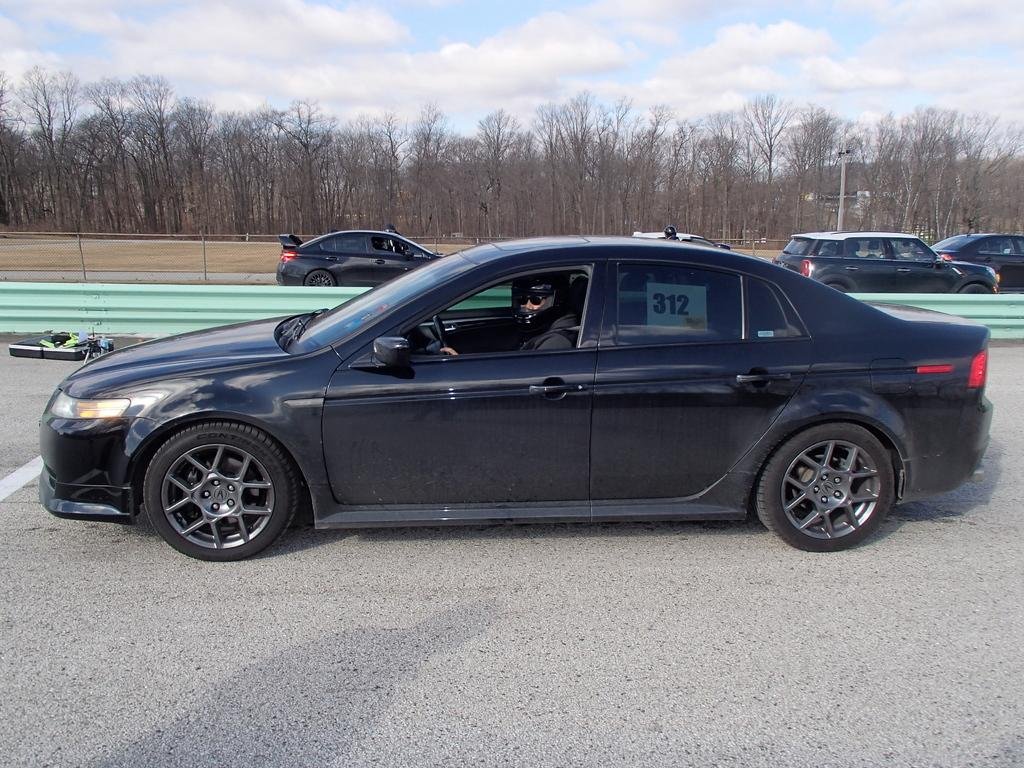What is the person in the image doing? The person is sitting inside a car. What protective gear is the person wearing? The person is wearing a helmet. What can be seen on the road in the image? There are cars on the road. What type of barrier is present in the image? There is a fence in the image. What is visible in the background of the image? There is a pole, trees, and the sky with clouds visible in the background. What type of pets can be seen playing with the ducks in the image? There are no pets or ducks present in the image; it features a person sitting in a car with a helmet, cars on the road, a fence, a pole, trees, and the sky with clouds in the background. 